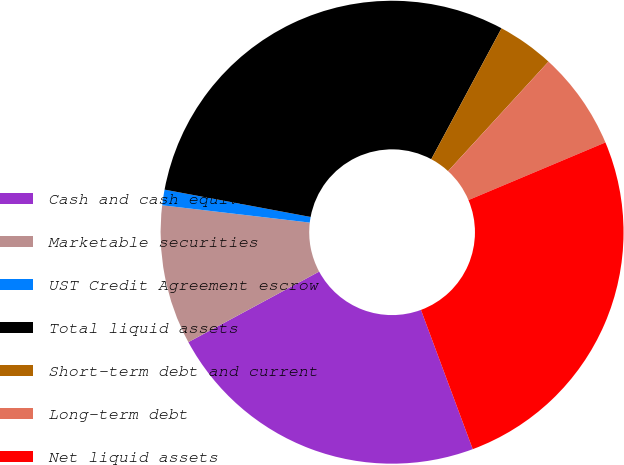Convert chart to OTSL. <chart><loc_0><loc_0><loc_500><loc_500><pie_chart><fcel>Cash and cash equivalents<fcel>Marketable securities<fcel>UST Credit Agreement escrow<fcel>Total liquid assets<fcel>Short-term debt and current<fcel>Long-term debt<fcel>Net liquid assets<nl><fcel>22.79%<fcel>9.73%<fcel>1.09%<fcel>29.89%<fcel>3.97%<fcel>6.85%<fcel>25.67%<nl></chart> 